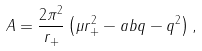<formula> <loc_0><loc_0><loc_500><loc_500>A = \frac { 2 \pi ^ { 2 } } { r _ { + } } \left ( \mu r _ { + } ^ { 2 } - a b q - q ^ { 2 } \right ) ,</formula> 